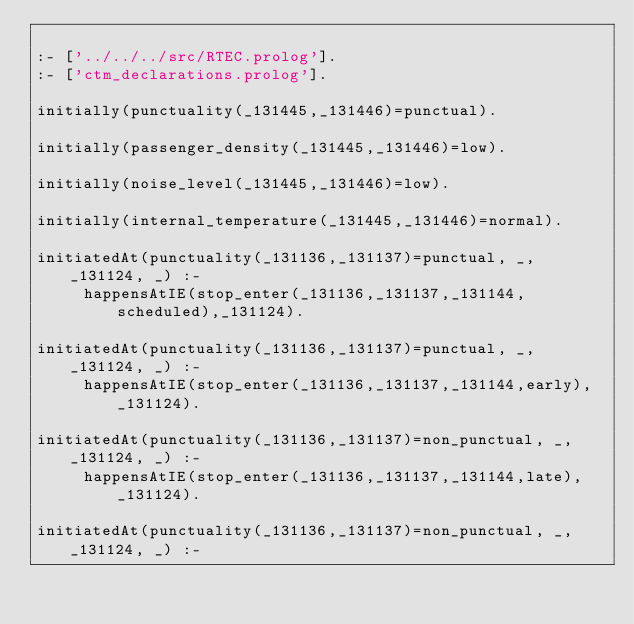<code> <loc_0><loc_0><loc_500><loc_500><_Prolog_>
:- ['../../../src/RTEC.prolog'].
:- ['ctm_declarations.prolog'].

initially(punctuality(_131445,_131446)=punctual).

initially(passenger_density(_131445,_131446)=low).

initially(noise_level(_131445,_131446)=low).

initially(internal_temperature(_131445,_131446)=normal).

initiatedAt(punctuality(_131136,_131137)=punctual, _, _131124, _) :-
     happensAtIE(stop_enter(_131136,_131137,_131144,scheduled),_131124).

initiatedAt(punctuality(_131136,_131137)=punctual, _, _131124, _) :-
     happensAtIE(stop_enter(_131136,_131137,_131144,early),_131124).

initiatedAt(punctuality(_131136,_131137)=non_punctual, _, _131124, _) :-
     happensAtIE(stop_enter(_131136,_131137,_131144,late),_131124).

initiatedAt(punctuality(_131136,_131137)=non_punctual, _, _131124, _) :-</code> 